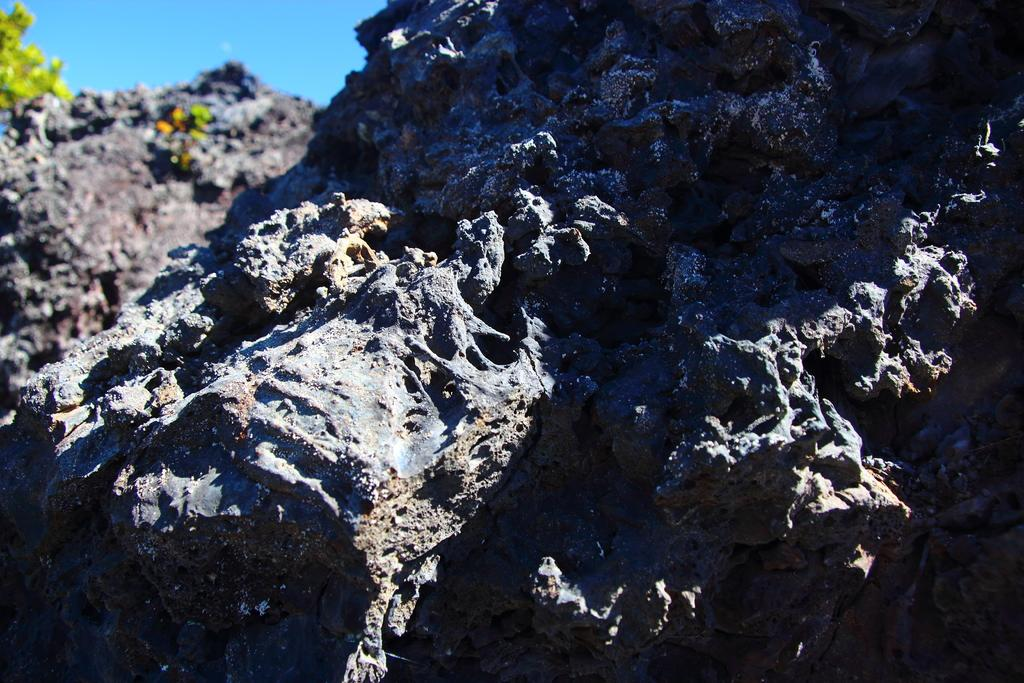What type of terrain is visible in the image? There are rocky hills in the image. Are there any plants on the hills? Yes, the hills have plants on them. What color is the sky in the image? The sky is blue in the image. What type of surprise can be seen in the image? There is no surprise present in the image; it features rocky hills with plants and a blue sky. Is there any poison visible in the image? There is no poison present in the image. 